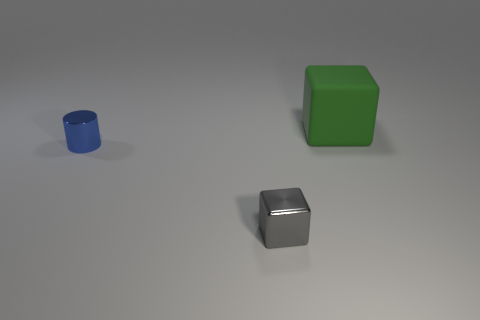Is there any other thing that is the same shape as the blue object?
Your answer should be compact. No. Are there fewer big green cubes to the left of the big green matte thing than small cyan matte balls?
Provide a succinct answer. No. How many small brown metal blocks are there?
Ensure brevity in your answer.  0. What number of tiny things are the same material as the small blue cylinder?
Keep it short and to the point. 1. What number of objects are either things in front of the green rubber thing or green blocks?
Give a very brief answer. 3. Are there fewer metal cylinders in front of the matte thing than blue things in front of the small gray object?
Your answer should be very brief. No. Are there any metal cubes right of the cylinder?
Offer a terse response. Yes. What number of objects are either metal things on the left side of the gray metal block or shiny objects on the left side of the tiny gray metal thing?
Offer a terse response. 1. What color is the other thing that is the same shape as the green thing?
Your response must be concise. Gray. What is the shape of the object that is both behind the tiny gray cube and left of the big green block?
Provide a short and direct response. Cylinder. 